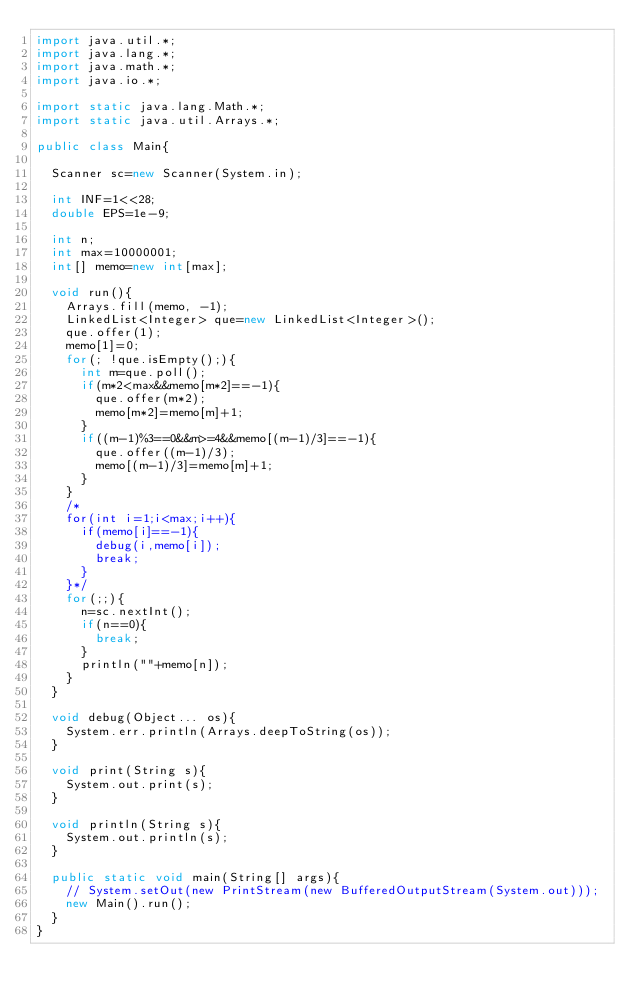<code> <loc_0><loc_0><loc_500><loc_500><_Java_>import java.util.*;
import java.lang.*;
import java.math.*;
import java.io.*;

import static java.lang.Math.*;
import static java.util.Arrays.*;

public class Main{

	Scanner sc=new Scanner(System.in);

	int INF=1<<28;
	double EPS=1e-9;

	int n;
	int max=10000001;
	int[] memo=new int[max];

	void run(){
		Arrays.fill(memo, -1);
		LinkedList<Integer> que=new LinkedList<Integer>();
		que.offer(1);
		memo[1]=0;
		for(; !que.isEmpty();){
			int m=que.poll();
			if(m*2<max&&memo[m*2]==-1){
				que.offer(m*2);
				memo[m*2]=memo[m]+1;
			}
			if((m-1)%3==0&&m>=4&&memo[(m-1)/3]==-1){
				que.offer((m-1)/3);
				memo[(m-1)/3]=memo[m]+1;
			}
		}
		/*
		for(int i=1;i<max;i++){
			if(memo[i]==-1){
				debug(i,memo[i]);
				break;
			}
		}*/
		for(;;){
			n=sc.nextInt();
			if(n==0){
				break;
			}
			println(""+memo[n]);
		}
	}

	void debug(Object... os){
		System.err.println(Arrays.deepToString(os));
	}

	void print(String s){
		System.out.print(s);
	}

	void println(String s){
		System.out.println(s);
	}

	public static void main(String[] args){
		// System.setOut(new PrintStream(new BufferedOutputStream(System.out)));
		new Main().run();
	}
}</code> 